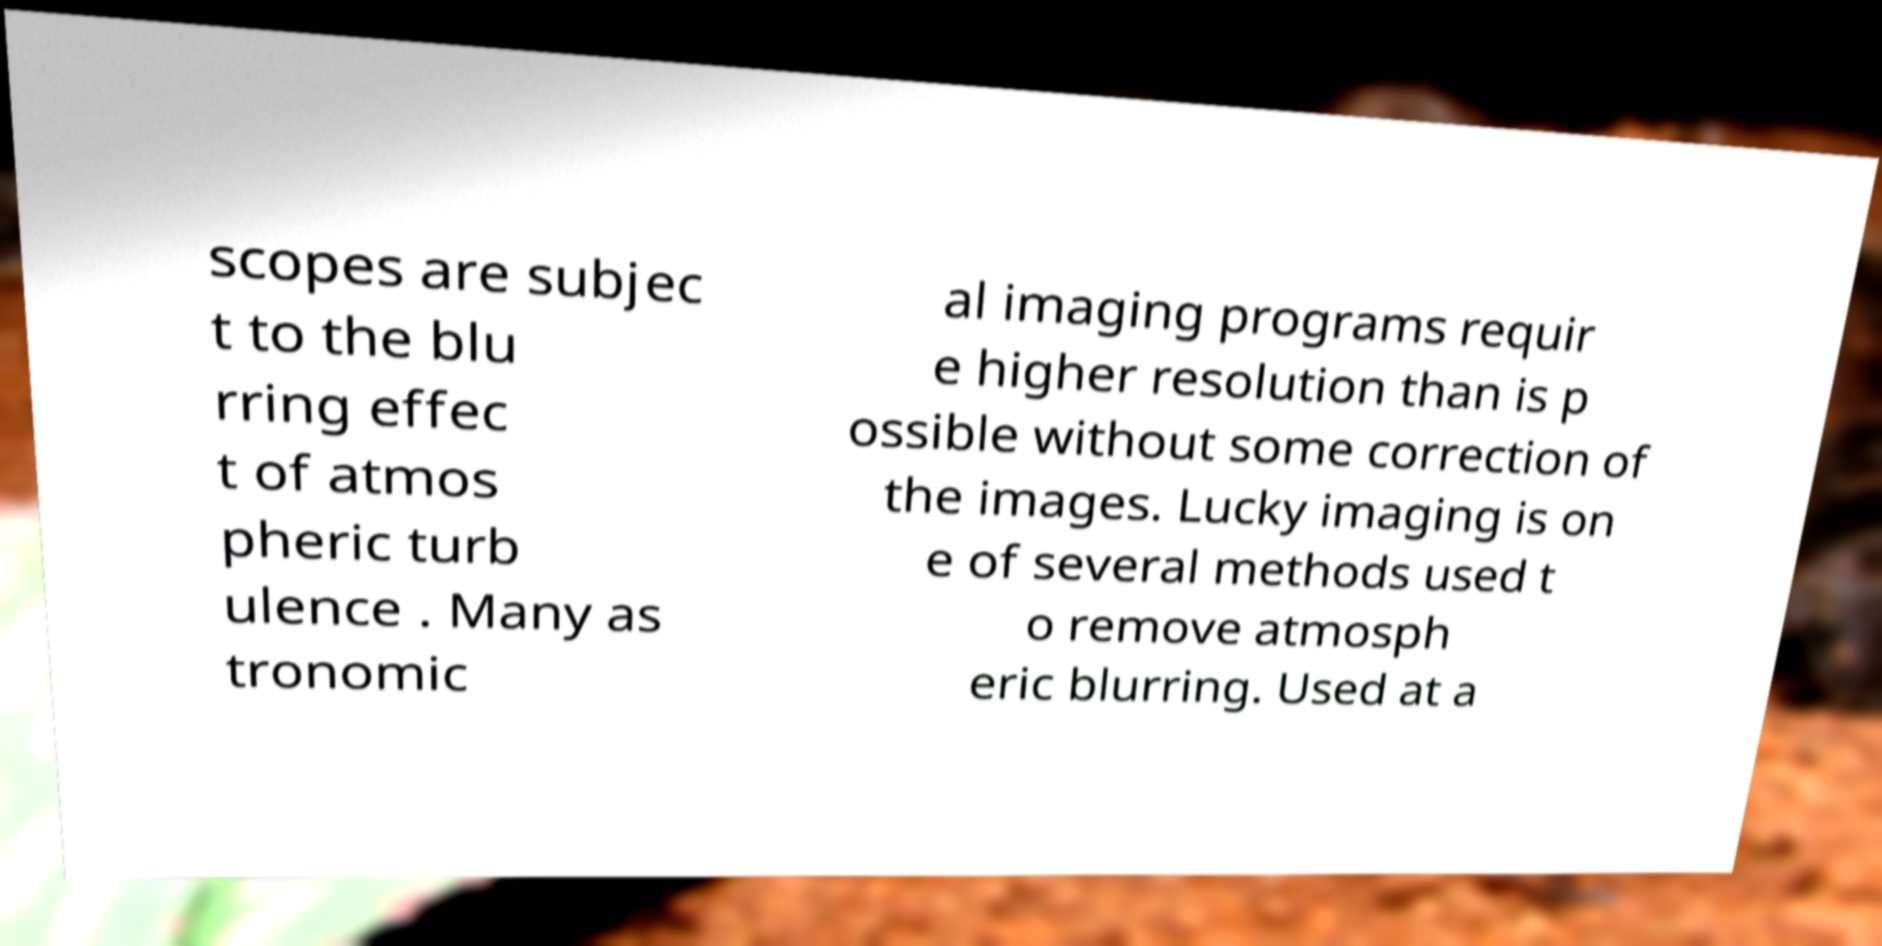Could you assist in decoding the text presented in this image and type it out clearly? scopes are subjec t to the blu rring effec t of atmos pheric turb ulence . Many as tronomic al imaging programs requir e higher resolution than is p ossible without some correction of the images. Lucky imaging is on e of several methods used t o remove atmosph eric blurring. Used at a 